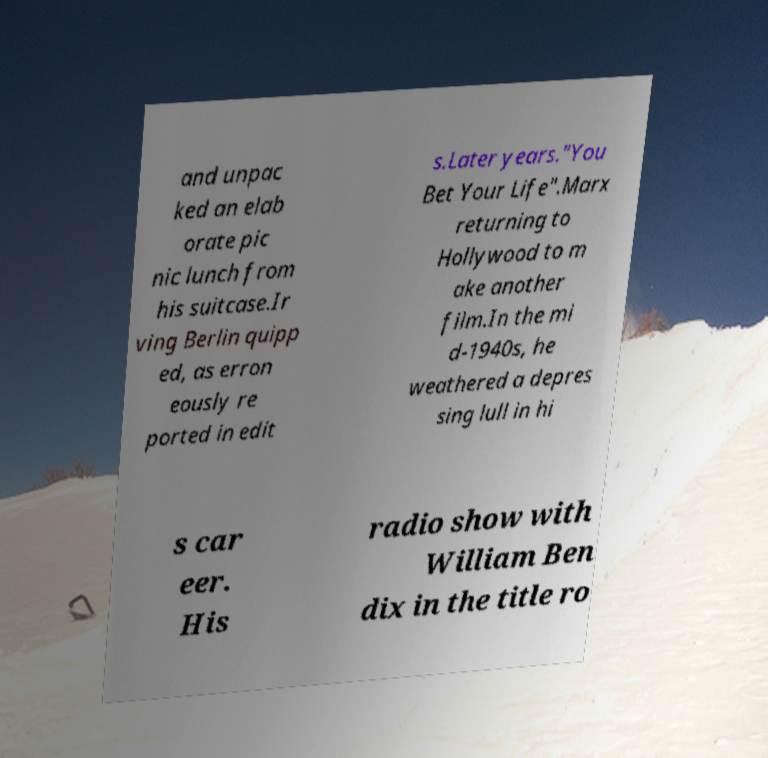Please read and relay the text visible in this image. What does it say? and unpac ked an elab orate pic nic lunch from his suitcase.Ir ving Berlin quipp ed, as erron eously re ported in edit s.Later years."You Bet Your Life".Marx returning to Hollywood to m ake another film.In the mi d-1940s, he weathered a depres sing lull in hi s car eer. His radio show with William Ben dix in the title ro 